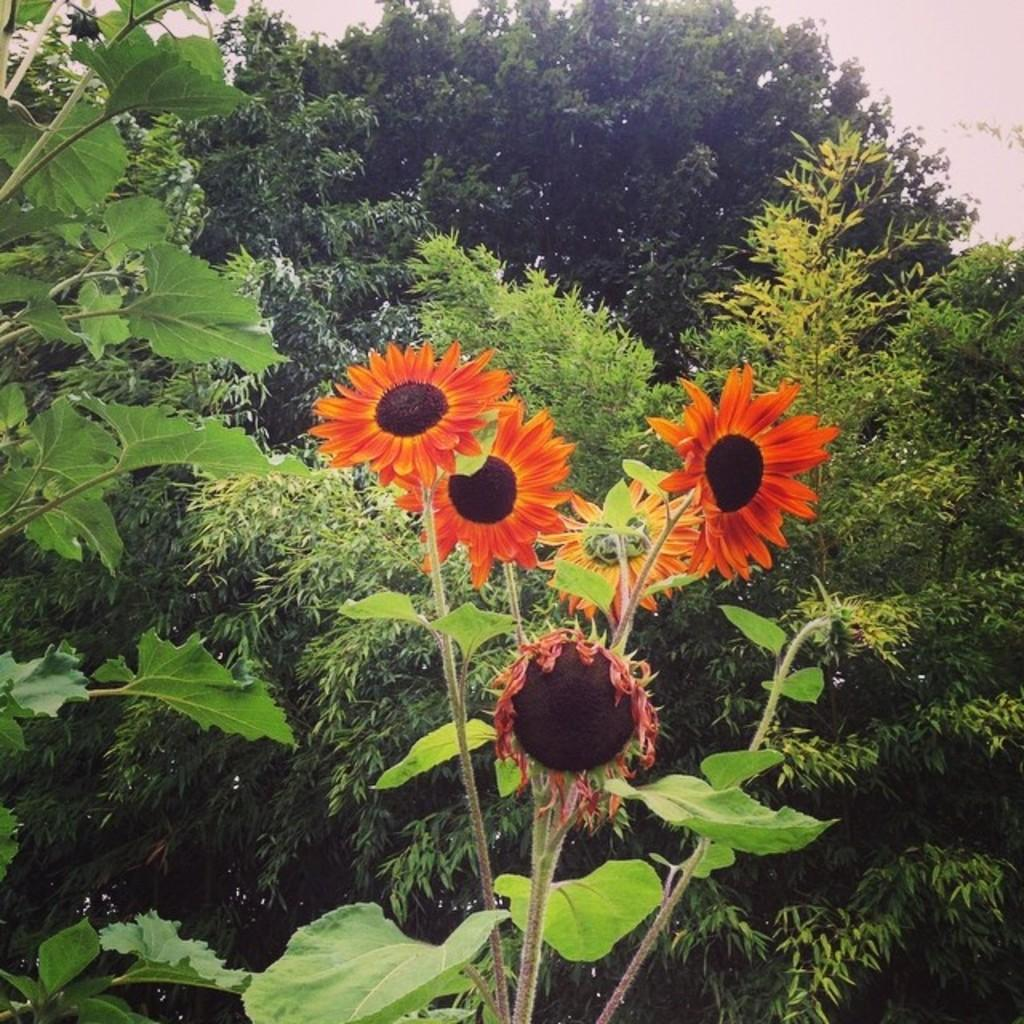What type of vegetation can be seen in the image? There are flowers, plants, and trees in the image. Can you describe the different types of vegetation present? The image contains flowers, which are smaller and more colorful, plants, which are typically green and leafy, and trees, which are larger and have a trunk. What type of note is being played by the donkey in the image? There is no donkey present in the image, and therefore no note being played. 